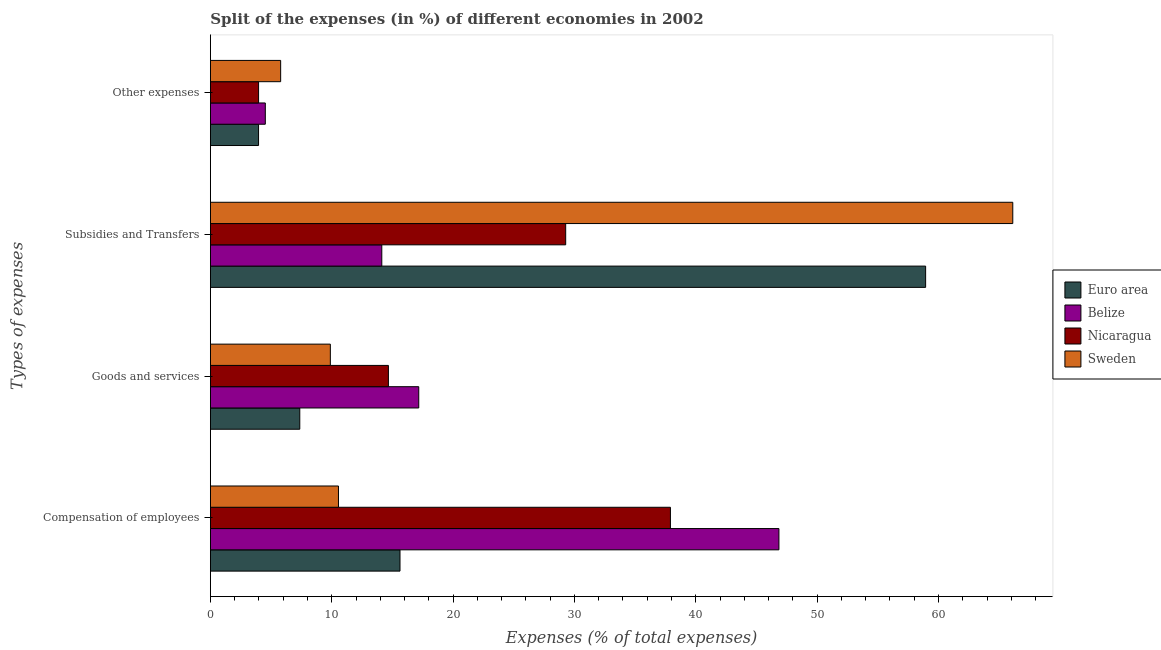What is the label of the 2nd group of bars from the top?
Offer a terse response. Subsidies and Transfers. What is the percentage of amount spent on compensation of employees in Belize?
Ensure brevity in your answer.  46.85. Across all countries, what is the maximum percentage of amount spent on compensation of employees?
Make the answer very short. 46.85. Across all countries, what is the minimum percentage of amount spent on goods and services?
Offer a terse response. 7.37. In which country was the percentage of amount spent on subsidies minimum?
Provide a succinct answer. Belize. What is the total percentage of amount spent on subsidies in the graph?
Offer a terse response. 168.47. What is the difference between the percentage of amount spent on other expenses in Euro area and that in Nicaragua?
Your answer should be very brief. -0. What is the difference between the percentage of amount spent on compensation of employees in Belize and the percentage of amount spent on goods and services in Nicaragua?
Offer a very short reply. 32.18. What is the average percentage of amount spent on compensation of employees per country?
Make the answer very short. 27.74. What is the difference between the percentage of amount spent on other expenses and percentage of amount spent on goods and services in Belize?
Your answer should be very brief. -12.64. What is the ratio of the percentage of amount spent on subsidies in Sweden to that in Euro area?
Provide a succinct answer. 1.12. What is the difference between the highest and the second highest percentage of amount spent on subsidies?
Your response must be concise. 7.18. What is the difference between the highest and the lowest percentage of amount spent on compensation of employees?
Offer a very short reply. 36.3. How many bars are there?
Your answer should be very brief. 16. What is the difference between two consecutive major ticks on the X-axis?
Provide a succinct answer. 10. Does the graph contain any zero values?
Keep it short and to the point. No. Does the graph contain grids?
Offer a very short reply. No. Where does the legend appear in the graph?
Keep it short and to the point. Center right. How many legend labels are there?
Your response must be concise. 4. How are the legend labels stacked?
Your answer should be very brief. Vertical. What is the title of the graph?
Provide a short and direct response. Split of the expenses (in %) of different economies in 2002. Does "Philippines" appear as one of the legend labels in the graph?
Your response must be concise. No. What is the label or title of the X-axis?
Ensure brevity in your answer.  Expenses (% of total expenses). What is the label or title of the Y-axis?
Make the answer very short. Types of expenses. What is the Expenses (% of total expenses) in Euro area in Compensation of employees?
Provide a short and direct response. 15.63. What is the Expenses (% of total expenses) of Belize in Compensation of employees?
Your answer should be compact. 46.85. What is the Expenses (% of total expenses) of Nicaragua in Compensation of employees?
Ensure brevity in your answer.  37.91. What is the Expenses (% of total expenses) of Sweden in Compensation of employees?
Offer a very short reply. 10.56. What is the Expenses (% of total expenses) of Euro area in Goods and services?
Provide a succinct answer. 7.37. What is the Expenses (% of total expenses) of Belize in Goods and services?
Keep it short and to the point. 17.17. What is the Expenses (% of total expenses) in Nicaragua in Goods and services?
Keep it short and to the point. 14.67. What is the Expenses (% of total expenses) in Sweden in Goods and services?
Ensure brevity in your answer.  9.89. What is the Expenses (% of total expenses) in Euro area in Subsidies and Transfers?
Keep it short and to the point. 58.94. What is the Expenses (% of total expenses) in Belize in Subsidies and Transfers?
Ensure brevity in your answer.  14.13. What is the Expenses (% of total expenses) of Nicaragua in Subsidies and Transfers?
Your answer should be very brief. 29.28. What is the Expenses (% of total expenses) in Sweden in Subsidies and Transfers?
Ensure brevity in your answer.  66.12. What is the Expenses (% of total expenses) of Euro area in Other expenses?
Your answer should be compact. 3.97. What is the Expenses (% of total expenses) in Belize in Other expenses?
Keep it short and to the point. 4.53. What is the Expenses (% of total expenses) in Nicaragua in Other expenses?
Give a very brief answer. 3.97. What is the Expenses (% of total expenses) in Sweden in Other expenses?
Keep it short and to the point. 5.79. Across all Types of expenses, what is the maximum Expenses (% of total expenses) in Euro area?
Make the answer very short. 58.94. Across all Types of expenses, what is the maximum Expenses (% of total expenses) in Belize?
Provide a short and direct response. 46.85. Across all Types of expenses, what is the maximum Expenses (% of total expenses) in Nicaragua?
Offer a terse response. 37.91. Across all Types of expenses, what is the maximum Expenses (% of total expenses) in Sweden?
Your response must be concise. 66.12. Across all Types of expenses, what is the minimum Expenses (% of total expenses) of Euro area?
Keep it short and to the point. 3.97. Across all Types of expenses, what is the minimum Expenses (% of total expenses) of Belize?
Make the answer very short. 4.53. Across all Types of expenses, what is the minimum Expenses (% of total expenses) in Nicaragua?
Give a very brief answer. 3.97. Across all Types of expenses, what is the minimum Expenses (% of total expenses) in Sweden?
Make the answer very short. 5.79. What is the total Expenses (% of total expenses) in Euro area in the graph?
Provide a succinct answer. 85.9. What is the total Expenses (% of total expenses) of Belize in the graph?
Your answer should be very brief. 82.68. What is the total Expenses (% of total expenses) in Nicaragua in the graph?
Offer a very short reply. 85.83. What is the total Expenses (% of total expenses) of Sweden in the graph?
Keep it short and to the point. 92.36. What is the difference between the Expenses (% of total expenses) in Euro area in Compensation of employees and that in Goods and services?
Give a very brief answer. 8.26. What is the difference between the Expenses (% of total expenses) of Belize in Compensation of employees and that in Goods and services?
Keep it short and to the point. 29.68. What is the difference between the Expenses (% of total expenses) in Nicaragua in Compensation of employees and that in Goods and services?
Ensure brevity in your answer.  23.24. What is the difference between the Expenses (% of total expenses) in Sweden in Compensation of employees and that in Goods and services?
Provide a succinct answer. 0.67. What is the difference between the Expenses (% of total expenses) in Euro area in Compensation of employees and that in Subsidies and Transfers?
Your answer should be compact. -43.32. What is the difference between the Expenses (% of total expenses) in Belize in Compensation of employees and that in Subsidies and Transfers?
Offer a terse response. 32.73. What is the difference between the Expenses (% of total expenses) of Nicaragua in Compensation of employees and that in Subsidies and Transfers?
Your answer should be compact. 8.63. What is the difference between the Expenses (% of total expenses) of Sweden in Compensation of employees and that in Subsidies and Transfers?
Provide a short and direct response. -55.57. What is the difference between the Expenses (% of total expenses) in Euro area in Compensation of employees and that in Other expenses?
Your answer should be compact. 11.66. What is the difference between the Expenses (% of total expenses) of Belize in Compensation of employees and that in Other expenses?
Offer a terse response. 42.33. What is the difference between the Expenses (% of total expenses) in Nicaragua in Compensation of employees and that in Other expenses?
Provide a short and direct response. 33.94. What is the difference between the Expenses (% of total expenses) of Sweden in Compensation of employees and that in Other expenses?
Provide a short and direct response. 4.77. What is the difference between the Expenses (% of total expenses) of Euro area in Goods and services and that in Subsidies and Transfers?
Provide a succinct answer. -51.57. What is the difference between the Expenses (% of total expenses) in Belize in Goods and services and that in Subsidies and Transfers?
Your answer should be compact. 3.05. What is the difference between the Expenses (% of total expenses) in Nicaragua in Goods and services and that in Subsidies and Transfers?
Provide a succinct answer. -14.61. What is the difference between the Expenses (% of total expenses) in Sweden in Goods and services and that in Subsidies and Transfers?
Give a very brief answer. -56.24. What is the difference between the Expenses (% of total expenses) of Euro area in Goods and services and that in Other expenses?
Offer a very short reply. 3.4. What is the difference between the Expenses (% of total expenses) in Belize in Goods and services and that in Other expenses?
Provide a short and direct response. 12.64. What is the difference between the Expenses (% of total expenses) of Nicaragua in Goods and services and that in Other expenses?
Offer a very short reply. 10.7. What is the difference between the Expenses (% of total expenses) of Sweden in Goods and services and that in Other expenses?
Ensure brevity in your answer.  4.09. What is the difference between the Expenses (% of total expenses) in Euro area in Subsidies and Transfers and that in Other expenses?
Keep it short and to the point. 54.97. What is the difference between the Expenses (% of total expenses) in Belize in Subsidies and Transfers and that in Other expenses?
Provide a short and direct response. 9.6. What is the difference between the Expenses (% of total expenses) of Nicaragua in Subsidies and Transfers and that in Other expenses?
Provide a short and direct response. 25.31. What is the difference between the Expenses (% of total expenses) in Sweden in Subsidies and Transfers and that in Other expenses?
Offer a very short reply. 60.33. What is the difference between the Expenses (% of total expenses) of Euro area in Compensation of employees and the Expenses (% of total expenses) of Belize in Goods and services?
Keep it short and to the point. -1.54. What is the difference between the Expenses (% of total expenses) in Euro area in Compensation of employees and the Expenses (% of total expenses) in Nicaragua in Goods and services?
Your response must be concise. 0.96. What is the difference between the Expenses (% of total expenses) in Euro area in Compensation of employees and the Expenses (% of total expenses) in Sweden in Goods and services?
Ensure brevity in your answer.  5.74. What is the difference between the Expenses (% of total expenses) of Belize in Compensation of employees and the Expenses (% of total expenses) of Nicaragua in Goods and services?
Offer a very short reply. 32.18. What is the difference between the Expenses (% of total expenses) of Belize in Compensation of employees and the Expenses (% of total expenses) of Sweden in Goods and services?
Provide a short and direct response. 36.97. What is the difference between the Expenses (% of total expenses) of Nicaragua in Compensation of employees and the Expenses (% of total expenses) of Sweden in Goods and services?
Offer a very short reply. 28.03. What is the difference between the Expenses (% of total expenses) of Euro area in Compensation of employees and the Expenses (% of total expenses) of Belize in Subsidies and Transfers?
Your answer should be compact. 1.5. What is the difference between the Expenses (% of total expenses) of Euro area in Compensation of employees and the Expenses (% of total expenses) of Nicaragua in Subsidies and Transfers?
Provide a short and direct response. -13.65. What is the difference between the Expenses (% of total expenses) of Euro area in Compensation of employees and the Expenses (% of total expenses) of Sweden in Subsidies and Transfers?
Offer a very short reply. -50.5. What is the difference between the Expenses (% of total expenses) in Belize in Compensation of employees and the Expenses (% of total expenses) in Nicaragua in Subsidies and Transfers?
Make the answer very short. 17.57. What is the difference between the Expenses (% of total expenses) in Belize in Compensation of employees and the Expenses (% of total expenses) in Sweden in Subsidies and Transfers?
Your answer should be compact. -19.27. What is the difference between the Expenses (% of total expenses) of Nicaragua in Compensation of employees and the Expenses (% of total expenses) of Sweden in Subsidies and Transfers?
Your response must be concise. -28.21. What is the difference between the Expenses (% of total expenses) of Euro area in Compensation of employees and the Expenses (% of total expenses) of Belize in Other expenses?
Ensure brevity in your answer.  11.1. What is the difference between the Expenses (% of total expenses) of Euro area in Compensation of employees and the Expenses (% of total expenses) of Nicaragua in Other expenses?
Provide a short and direct response. 11.65. What is the difference between the Expenses (% of total expenses) of Euro area in Compensation of employees and the Expenses (% of total expenses) of Sweden in Other expenses?
Make the answer very short. 9.84. What is the difference between the Expenses (% of total expenses) in Belize in Compensation of employees and the Expenses (% of total expenses) in Nicaragua in Other expenses?
Your answer should be compact. 42.88. What is the difference between the Expenses (% of total expenses) of Belize in Compensation of employees and the Expenses (% of total expenses) of Sweden in Other expenses?
Your response must be concise. 41.06. What is the difference between the Expenses (% of total expenses) in Nicaragua in Compensation of employees and the Expenses (% of total expenses) in Sweden in Other expenses?
Your answer should be very brief. 32.12. What is the difference between the Expenses (% of total expenses) in Euro area in Goods and services and the Expenses (% of total expenses) in Belize in Subsidies and Transfers?
Offer a very short reply. -6.76. What is the difference between the Expenses (% of total expenses) of Euro area in Goods and services and the Expenses (% of total expenses) of Nicaragua in Subsidies and Transfers?
Provide a succinct answer. -21.91. What is the difference between the Expenses (% of total expenses) in Euro area in Goods and services and the Expenses (% of total expenses) in Sweden in Subsidies and Transfers?
Provide a succinct answer. -58.76. What is the difference between the Expenses (% of total expenses) of Belize in Goods and services and the Expenses (% of total expenses) of Nicaragua in Subsidies and Transfers?
Your response must be concise. -12.11. What is the difference between the Expenses (% of total expenses) in Belize in Goods and services and the Expenses (% of total expenses) in Sweden in Subsidies and Transfers?
Provide a short and direct response. -48.95. What is the difference between the Expenses (% of total expenses) of Nicaragua in Goods and services and the Expenses (% of total expenses) of Sweden in Subsidies and Transfers?
Your answer should be compact. -51.45. What is the difference between the Expenses (% of total expenses) in Euro area in Goods and services and the Expenses (% of total expenses) in Belize in Other expenses?
Your answer should be very brief. 2.84. What is the difference between the Expenses (% of total expenses) in Euro area in Goods and services and the Expenses (% of total expenses) in Nicaragua in Other expenses?
Your answer should be compact. 3.4. What is the difference between the Expenses (% of total expenses) of Euro area in Goods and services and the Expenses (% of total expenses) of Sweden in Other expenses?
Your answer should be very brief. 1.58. What is the difference between the Expenses (% of total expenses) in Belize in Goods and services and the Expenses (% of total expenses) in Nicaragua in Other expenses?
Offer a terse response. 13.2. What is the difference between the Expenses (% of total expenses) in Belize in Goods and services and the Expenses (% of total expenses) in Sweden in Other expenses?
Your answer should be very brief. 11.38. What is the difference between the Expenses (% of total expenses) in Nicaragua in Goods and services and the Expenses (% of total expenses) in Sweden in Other expenses?
Give a very brief answer. 8.88. What is the difference between the Expenses (% of total expenses) of Euro area in Subsidies and Transfers and the Expenses (% of total expenses) of Belize in Other expenses?
Provide a short and direct response. 54.42. What is the difference between the Expenses (% of total expenses) in Euro area in Subsidies and Transfers and the Expenses (% of total expenses) in Nicaragua in Other expenses?
Your response must be concise. 54.97. What is the difference between the Expenses (% of total expenses) in Euro area in Subsidies and Transfers and the Expenses (% of total expenses) in Sweden in Other expenses?
Keep it short and to the point. 53.15. What is the difference between the Expenses (% of total expenses) of Belize in Subsidies and Transfers and the Expenses (% of total expenses) of Nicaragua in Other expenses?
Give a very brief answer. 10.15. What is the difference between the Expenses (% of total expenses) in Belize in Subsidies and Transfers and the Expenses (% of total expenses) in Sweden in Other expenses?
Keep it short and to the point. 8.33. What is the difference between the Expenses (% of total expenses) in Nicaragua in Subsidies and Transfers and the Expenses (% of total expenses) in Sweden in Other expenses?
Your response must be concise. 23.49. What is the average Expenses (% of total expenses) in Euro area per Types of expenses?
Your answer should be compact. 21.48. What is the average Expenses (% of total expenses) of Belize per Types of expenses?
Keep it short and to the point. 20.67. What is the average Expenses (% of total expenses) of Nicaragua per Types of expenses?
Provide a succinct answer. 21.46. What is the average Expenses (% of total expenses) of Sweden per Types of expenses?
Provide a short and direct response. 23.09. What is the difference between the Expenses (% of total expenses) in Euro area and Expenses (% of total expenses) in Belize in Compensation of employees?
Provide a short and direct response. -31.23. What is the difference between the Expenses (% of total expenses) of Euro area and Expenses (% of total expenses) of Nicaragua in Compensation of employees?
Your answer should be compact. -22.28. What is the difference between the Expenses (% of total expenses) of Euro area and Expenses (% of total expenses) of Sweden in Compensation of employees?
Offer a very short reply. 5.07. What is the difference between the Expenses (% of total expenses) of Belize and Expenses (% of total expenses) of Nicaragua in Compensation of employees?
Offer a terse response. 8.94. What is the difference between the Expenses (% of total expenses) of Belize and Expenses (% of total expenses) of Sweden in Compensation of employees?
Provide a short and direct response. 36.3. What is the difference between the Expenses (% of total expenses) in Nicaragua and Expenses (% of total expenses) in Sweden in Compensation of employees?
Keep it short and to the point. 27.36. What is the difference between the Expenses (% of total expenses) in Euro area and Expenses (% of total expenses) in Belize in Goods and services?
Give a very brief answer. -9.8. What is the difference between the Expenses (% of total expenses) of Euro area and Expenses (% of total expenses) of Nicaragua in Goods and services?
Provide a succinct answer. -7.3. What is the difference between the Expenses (% of total expenses) of Euro area and Expenses (% of total expenses) of Sweden in Goods and services?
Provide a short and direct response. -2.52. What is the difference between the Expenses (% of total expenses) of Belize and Expenses (% of total expenses) of Nicaragua in Goods and services?
Make the answer very short. 2.5. What is the difference between the Expenses (% of total expenses) of Belize and Expenses (% of total expenses) of Sweden in Goods and services?
Provide a short and direct response. 7.29. What is the difference between the Expenses (% of total expenses) in Nicaragua and Expenses (% of total expenses) in Sweden in Goods and services?
Keep it short and to the point. 4.79. What is the difference between the Expenses (% of total expenses) in Euro area and Expenses (% of total expenses) in Belize in Subsidies and Transfers?
Offer a terse response. 44.82. What is the difference between the Expenses (% of total expenses) of Euro area and Expenses (% of total expenses) of Nicaragua in Subsidies and Transfers?
Your answer should be very brief. 29.66. What is the difference between the Expenses (% of total expenses) in Euro area and Expenses (% of total expenses) in Sweden in Subsidies and Transfers?
Keep it short and to the point. -7.18. What is the difference between the Expenses (% of total expenses) of Belize and Expenses (% of total expenses) of Nicaragua in Subsidies and Transfers?
Keep it short and to the point. -15.15. What is the difference between the Expenses (% of total expenses) in Belize and Expenses (% of total expenses) in Sweden in Subsidies and Transfers?
Provide a short and direct response. -52. What is the difference between the Expenses (% of total expenses) of Nicaragua and Expenses (% of total expenses) of Sweden in Subsidies and Transfers?
Your response must be concise. -36.85. What is the difference between the Expenses (% of total expenses) of Euro area and Expenses (% of total expenses) of Belize in Other expenses?
Your response must be concise. -0.56. What is the difference between the Expenses (% of total expenses) of Euro area and Expenses (% of total expenses) of Nicaragua in Other expenses?
Provide a short and direct response. -0. What is the difference between the Expenses (% of total expenses) in Euro area and Expenses (% of total expenses) in Sweden in Other expenses?
Offer a very short reply. -1.82. What is the difference between the Expenses (% of total expenses) of Belize and Expenses (% of total expenses) of Nicaragua in Other expenses?
Offer a very short reply. 0.56. What is the difference between the Expenses (% of total expenses) of Belize and Expenses (% of total expenses) of Sweden in Other expenses?
Give a very brief answer. -1.26. What is the difference between the Expenses (% of total expenses) of Nicaragua and Expenses (% of total expenses) of Sweden in Other expenses?
Offer a terse response. -1.82. What is the ratio of the Expenses (% of total expenses) of Euro area in Compensation of employees to that in Goods and services?
Your answer should be compact. 2.12. What is the ratio of the Expenses (% of total expenses) of Belize in Compensation of employees to that in Goods and services?
Keep it short and to the point. 2.73. What is the ratio of the Expenses (% of total expenses) in Nicaragua in Compensation of employees to that in Goods and services?
Your answer should be very brief. 2.58. What is the ratio of the Expenses (% of total expenses) of Sweden in Compensation of employees to that in Goods and services?
Provide a succinct answer. 1.07. What is the ratio of the Expenses (% of total expenses) in Euro area in Compensation of employees to that in Subsidies and Transfers?
Your answer should be very brief. 0.27. What is the ratio of the Expenses (% of total expenses) in Belize in Compensation of employees to that in Subsidies and Transfers?
Your answer should be very brief. 3.32. What is the ratio of the Expenses (% of total expenses) in Nicaragua in Compensation of employees to that in Subsidies and Transfers?
Offer a terse response. 1.29. What is the ratio of the Expenses (% of total expenses) in Sweden in Compensation of employees to that in Subsidies and Transfers?
Your answer should be compact. 0.16. What is the ratio of the Expenses (% of total expenses) in Euro area in Compensation of employees to that in Other expenses?
Make the answer very short. 3.94. What is the ratio of the Expenses (% of total expenses) in Belize in Compensation of employees to that in Other expenses?
Offer a terse response. 10.35. What is the ratio of the Expenses (% of total expenses) of Nicaragua in Compensation of employees to that in Other expenses?
Provide a short and direct response. 9.55. What is the ratio of the Expenses (% of total expenses) of Sweden in Compensation of employees to that in Other expenses?
Ensure brevity in your answer.  1.82. What is the ratio of the Expenses (% of total expenses) in Belize in Goods and services to that in Subsidies and Transfers?
Make the answer very short. 1.22. What is the ratio of the Expenses (% of total expenses) in Nicaragua in Goods and services to that in Subsidies and Transfers?
Provide a succinct answer. 0.5. What is the ratio of the Expenses (% of total expenses) of Sweden in Goods and services to that in Subsidies and Transfers?
Your answer should be very brief. 0.15. What is the ratio of the Expenses (% of total expenses) of Euro area in Goods and services to that in Other expenses?
Your response must be concise. 1.86. What is the ratio of the Expenses (% of total expenses) of Belize in Goods and services to that in Other expenses?
Provide a short and direct response. 3.79. What is the ratio of the Expenses (% of total expenses) of Nicaragua in Goods and services to that in Other expenses?
Provide a short and direct response. 3.69. What is the ratio of the Expenses (% of total expenses) in Sweden in Goods and services to that in Other expenses?
Offer a very short reply. 1.71. What is the ratio of the Expenses (% of total expenses) of Euro area in Subsidies and Transfers to that in Other expenses?
Offer a very short reply. 14.85. What is the ratio of the Expenses (% of total expenses) of Belize in Subsidies and Transfers to that in Other expenses?
Ensure brevity in your answer.  3.12. What is the ratio of the Expenses (% of total expenses) of Nicaragua in Subsidies and Transfers to that in Other expenses?
Offer a very short reply. 7.37. What is the ratio of the Expenses (% of total expenses) in Sweden in Subsidies and Transfers to that in Other expenses?
Your answer should be very brief. 11.42. What is the difference between the highest and the second highest Expenses (% of total expenses) of Euro area?
Your response must be concise. 43.32. What is the difference between the highest and the second highest Expenses (% of total expenses) of Belize?
Make the answer very short. 29.68. What is the difference between the highest and the second highest Expenses (% of total expenses) in Nicaragua?
Provide a short and direct response. 8.63. What is the difference between the highest and the second highest Expenses (% of total expenses) in Sweden?
Ensure brevity in your answer.  55.57. What is the difference between the highest and the lowest Expenses (% of total expenses) of Euro area?
Give a very brief answer. 54.97. What is the difference between the highest and the lowest Expenses (% of total expenses) of Belize?
Your response must be concise. 42.33. What is the difference between the highest and the lowest Expenses (% of total expenses) in Nicaragua?
Your answer should be very brief. 33.94. What is the difference between the highest and the lowest Expenses (% of total expenses) in Sweden?
Offer a very short reply. 60.33. 